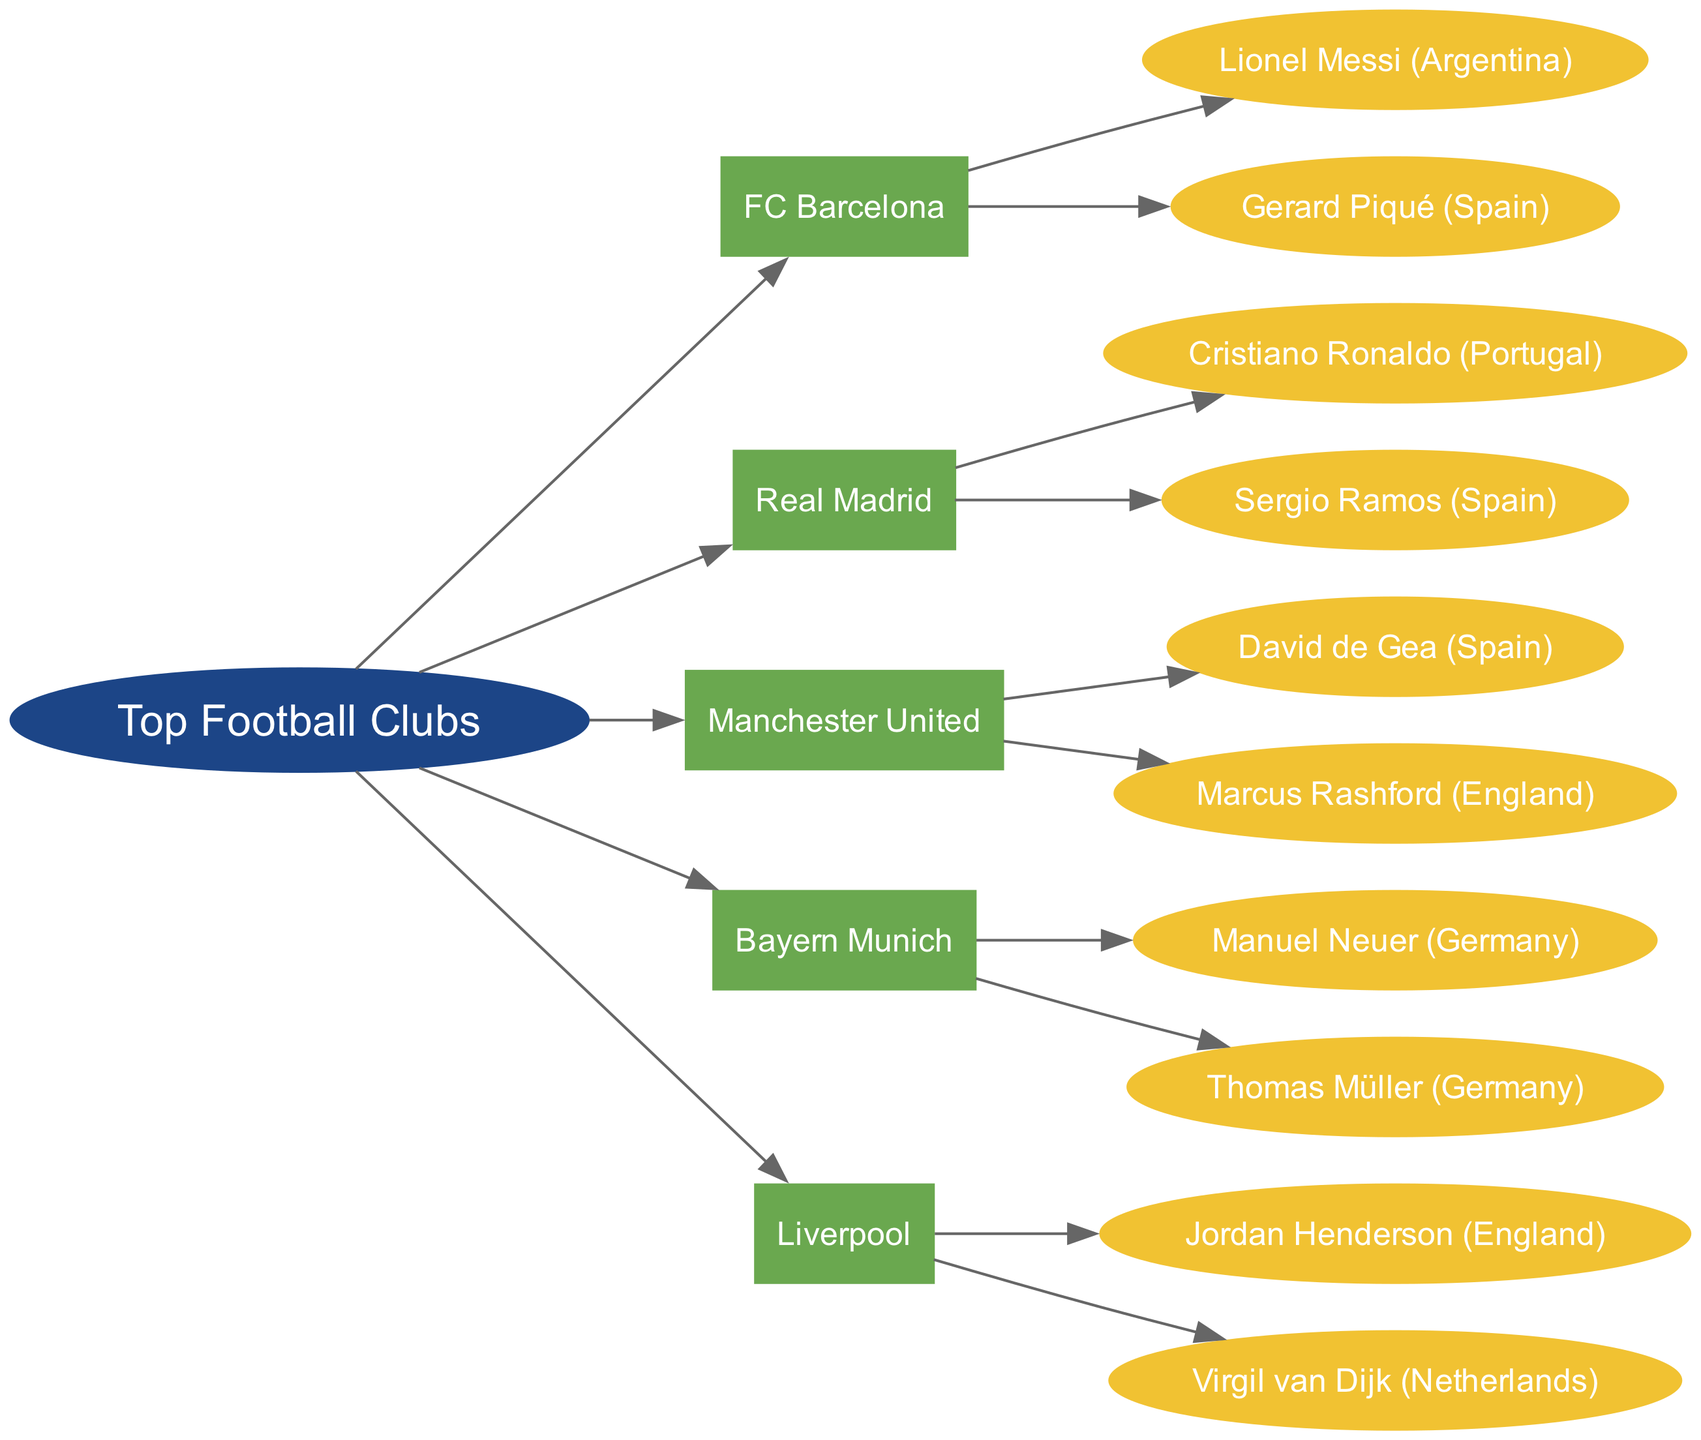What are the World Cup players from FC Barcelona? The flow chart indicates the players directly under the FC Barcelona node. They are Lionel Messi and Gerard Piqué, listed under the "World Cup Players" category for FC Barcelona.
Answer: Lionel Messi (Argentina), Gerard Piqué (Spain) How many World Cup players does Bayern Munich have? The diagram shows that Bayern Munich has two players listed under the "World Cup Players" node, which are Manuel Neuer and Thomas Müller.
Answer: 2 Which club has the player Cristiano Ronaldo? By tracing the diagram, we see that Cristiano Ronaldo is listed under Real Madrid, which indicates he is a player associated with that club.
Answer: Real Madrid What is the country of origin for Virgil van Dijk? In the flow chart, Virgil van Dijk is listed under the Liverpool club, and next to his name is the country Netherlands. Therefore, his country of origin is directly indicated in the diagram.
Answer: Netherlands How many clubs are depicted in the diagram? The diagram lists five clubs: FC Barcelona, Real Madrid, Manchester United, Bayern Munich, and Liverpool. By counting the club nodes under the "Top Football Clubs," we find there are five.
Answer: 5 Which club has players from Spain? The players associated with Spain in the diagram are Gerard Piqué from FC Barcelona, Sergio Ramos from Real Madrid, and David de Gea from Manchester United. This indicates that all three clubs are represented.
Answer: FC Barcelona, Real Madrid, Manchester United How many players from Manchester United are shown? The diagram indicates that Manchester United has two players listed under its "World Cup Players" category, which are David de Gea and Marcus Rashford.
Answer: 2 Which club has the most diverse player nationalities listed? The chart shows representation from various countries. But counting through the players, we see Liverpool has players from England and the Netherlands, thus having two different nationalities. Other clubs generally feature players primarily from one nationality or pair of them; hence, Liverpool stands out for this grouping.
Answer: Liverpool What is the relationship between Bayern Munich and the World Cup players? The diagram illustrates a direct connection from the Bayern Munich node to the "World Cup Players" node, leading to the nodes for Manuel Neuer and Thomas Müller. This indicates that these players represent Bayern Munich in World Cup events.
Answer: Direct connection to players 